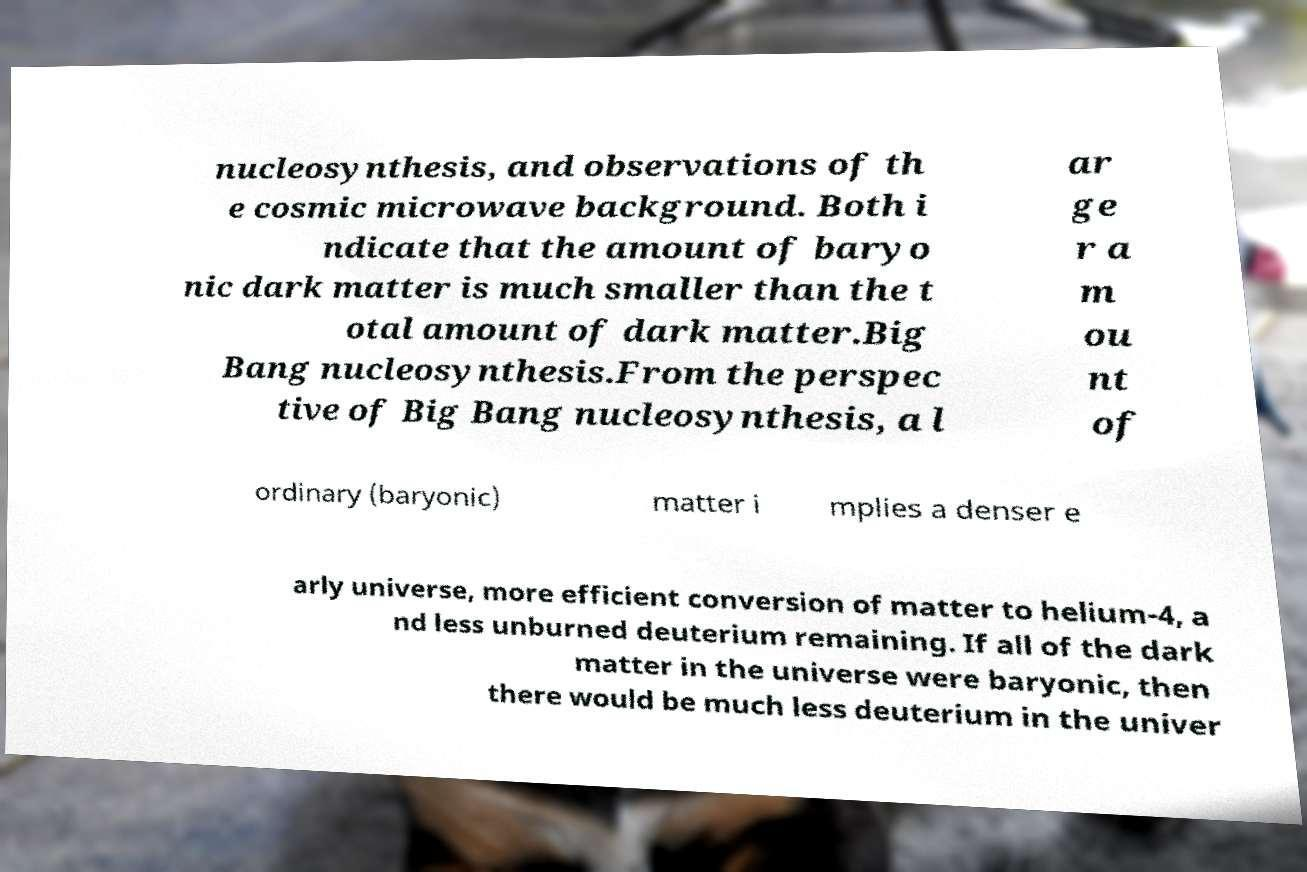I need the written content from this picture converted into text. Can you do that? nucleosynthesis, and observations of th e cosmic microwave background. Both i ndicate that the amount of baryo nic dark matter is much smaller than the t otal amount of dark matter.Big Bang nucleosynthesis.From the perspec tive of Big Bang nucleosynthesis, a l ar ge r a m ou nt of ordinary (baryonic) matter i mplies a denser e arly universe, more efficient conversion of matter to helium-4, a nd less unburned deuterium remaining. If all of the dark matter in the universe were baryonic, then there would be much less deuterium in the univer 